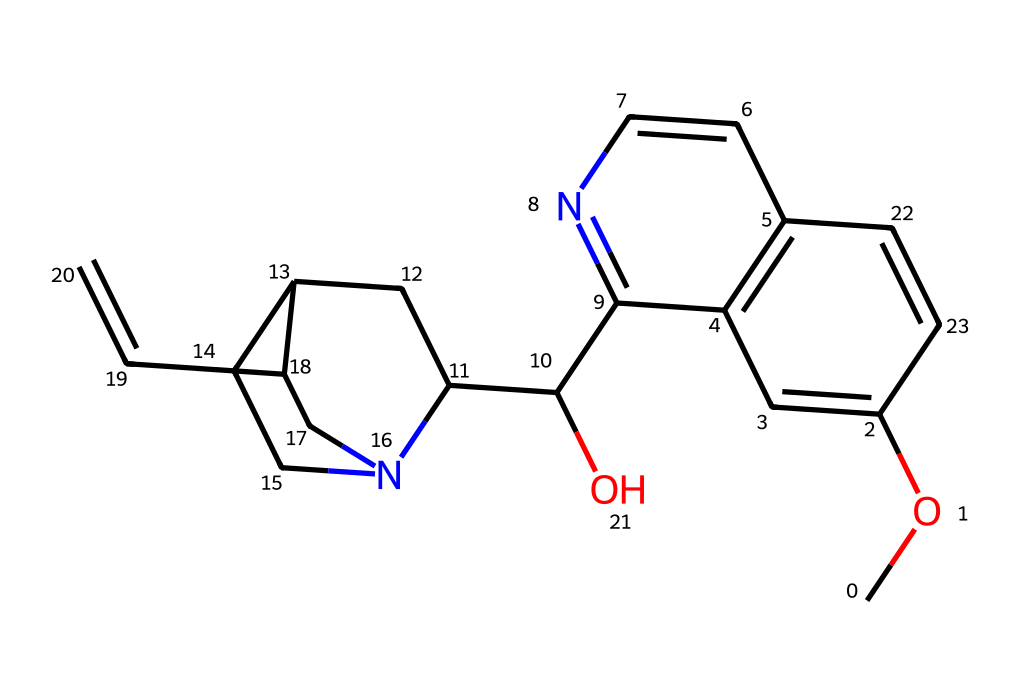What is the molecular formula of quinine? By analyzing the SMILES representation, we identify the number of carbon (C), hydrogen (H), nitrogen (N), and oxygen (O) atoms present. The structure has 20 carbon atoms, 24 hydrogen atoms, 1 nitrogen atom, and 1 oxygen atom. Thus, the molecular formula can be derived as C20H24N2O2.
Answer: C20H24N2O2 How many rings are present in the structure of quinine? By examining the chemical structure represented in the SMILES, we see multiple cyclic components. Specifically, there are two fused rings and one additional attached ring, totaling three distinct rings in the structure.
Answer: 3 What is the primary functional group observed in quinine? Reviewing the SMILES representation, we find an alcohol group (-OH) attached in the structure, indicating the presence of a hydroxyl functional group, which is a significant feature in the quinine molecule.
Answer: hydroxyl What type of chemical compound is quinine? Quinine is classified as an alkaloid based on its nitrogen-containing structure and biological activity, particularly as an antimalarial compound. This classification comes from its origin from plant sources and its physiological effects.
Answer: alkaloid What element is primarily responsible for the basic characteristics of quinine as an alkaloid? The nitrogen atom in the structure is crucial for defining alkaloids, as it influences the compound's pharmacological properties, including its bitter taste and interaction with biological systems. Hence, the nitrogen is essential in the identity of quinine as an alkaloid.
Answer: nitrogen 